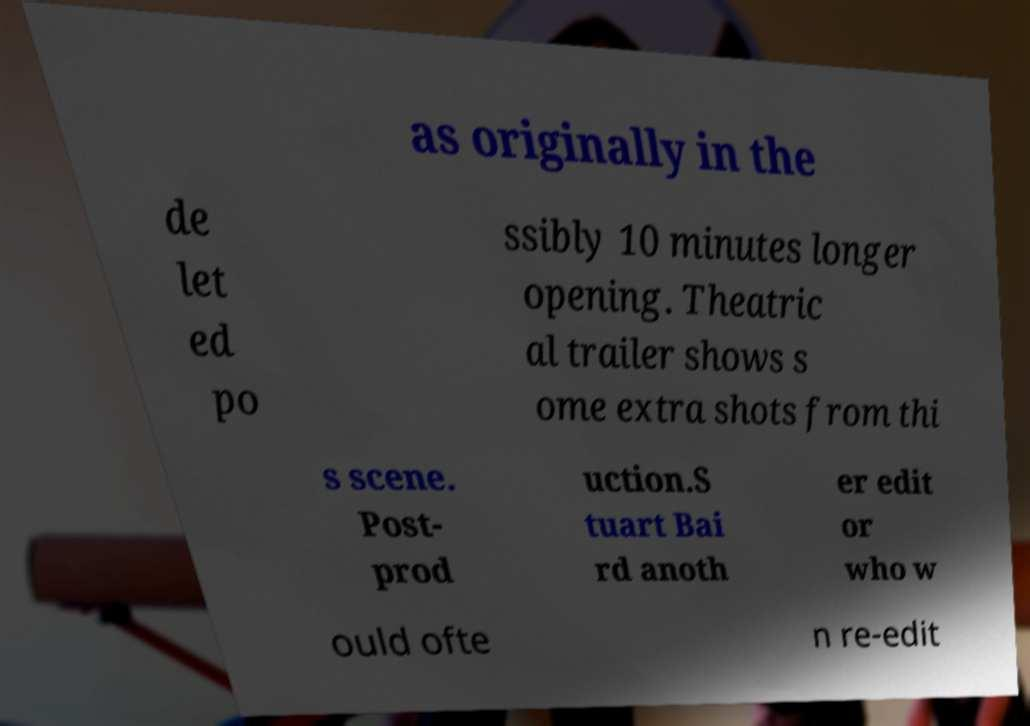Can you accurately transcribe the text from the provided image for me? as originally in the de let ed po ssibly 10 minutes longer opening. Theatric al trailer shows s ome extra shots from thi s scene. Post- prod uction.S tuart Bai rd anoth er edit or who w ould ofte n re-edit 